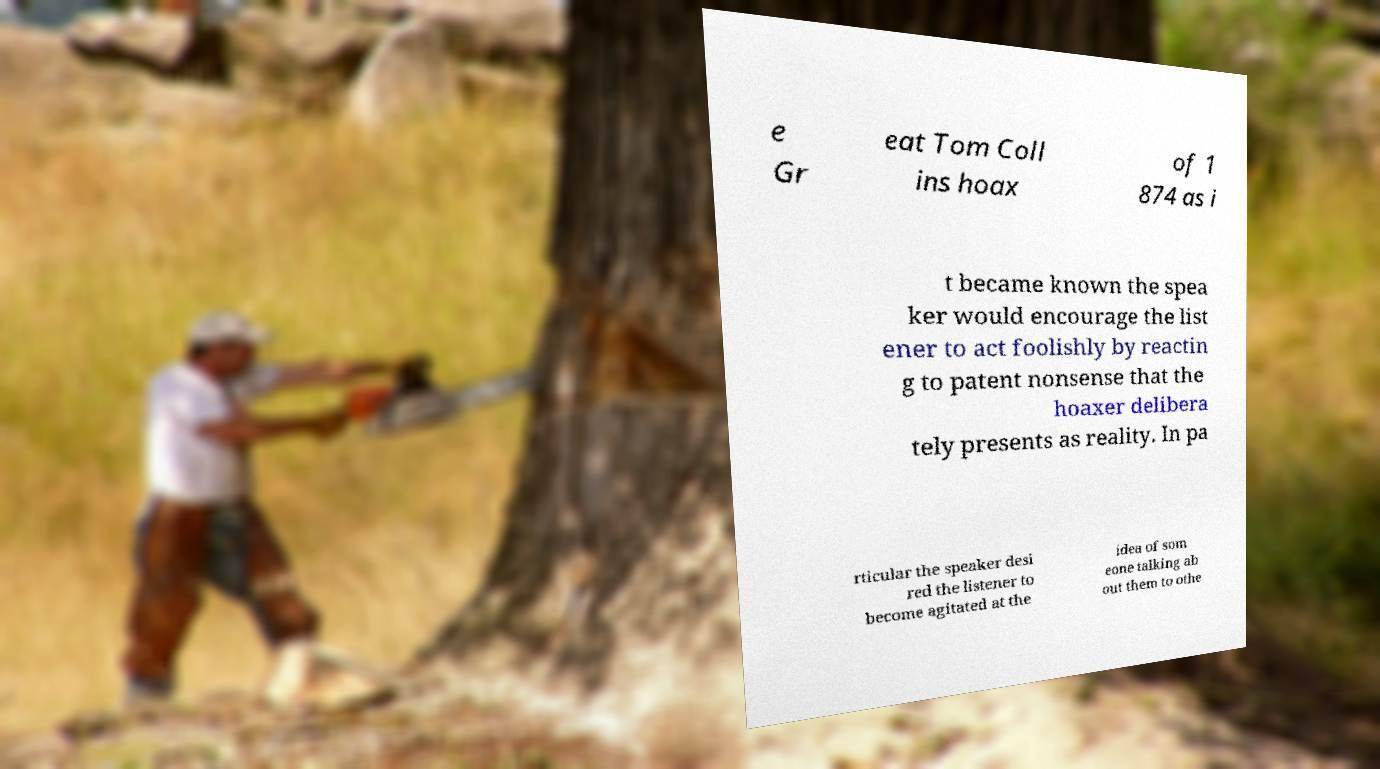There's text embedded in this image that I need extracted. Can you transcribe it verbatim? e Gr eat Tom Coll ins hoax of 1 874 as i t became known the spea ker would encourage the list ener to act foolishly by reactin g to patent nonsense that the hoaxer delibera tely presents as reality. In pa rticular the speaker desi red the listener to become agitated at the idea of som eone talking ab out them to othe 